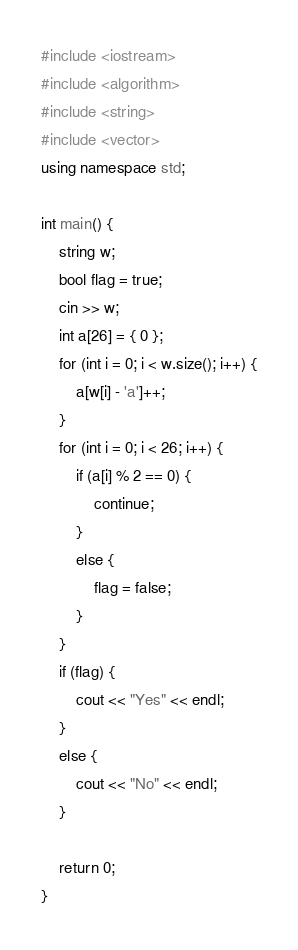Convert code to text. <code><loc_0><loc_0><loc_500><loc_500><_C++_>#include <iostream>
#include <algorithm>
#include <string>
#include <vector>
using namespace std;

int main() {
	string w;
	bool flag = true;
	cin >> w;
	int a[26] = { 0 };
	for (int i = 0; i < w.size(); i++) {
		a[w[i] - 'a']++;
	}
	for (int i = 0; i < 26; i++) {
		if (a[i] % 2 == 0) {
			continue;
		}
		else {
			flag = false;
		}
	}
	if (flag) {
		cout << "Yes" << endl;
	}
	else {
		cout << "No" << endl;
	}
	
	return 0;
}</code> 